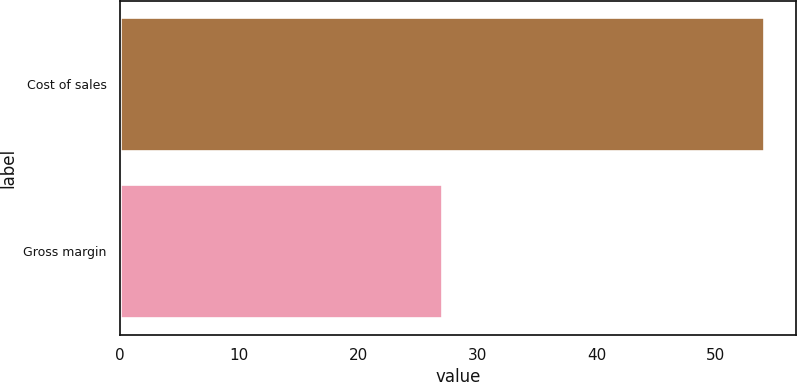<chart> <loc_0><loc_0><loc_500><loc_500><bar_chart><fcel>Cost of sales<fcel>Gross margin<nl><fcel>54<fcel>27<nl></chart> 